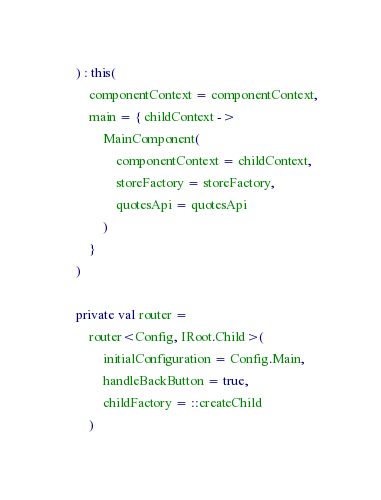<code> <loc_0><loc_0><loc_500><loc_500><_Kotlin_>    ) : this(
        componentContext = componentContext,
        main = { childContext ->
            MainComponent(
                componentContext = childContext,
                storeFactory = storeFactory,
                quotesApi = quotesApi
            )
        }
    )

    private val router =
        router<Config, IRoot.Child>(
            initialConfiguration = Config.Main,
            handleBackButton = true,
            childFactory = ::createChild
        )
</code> 